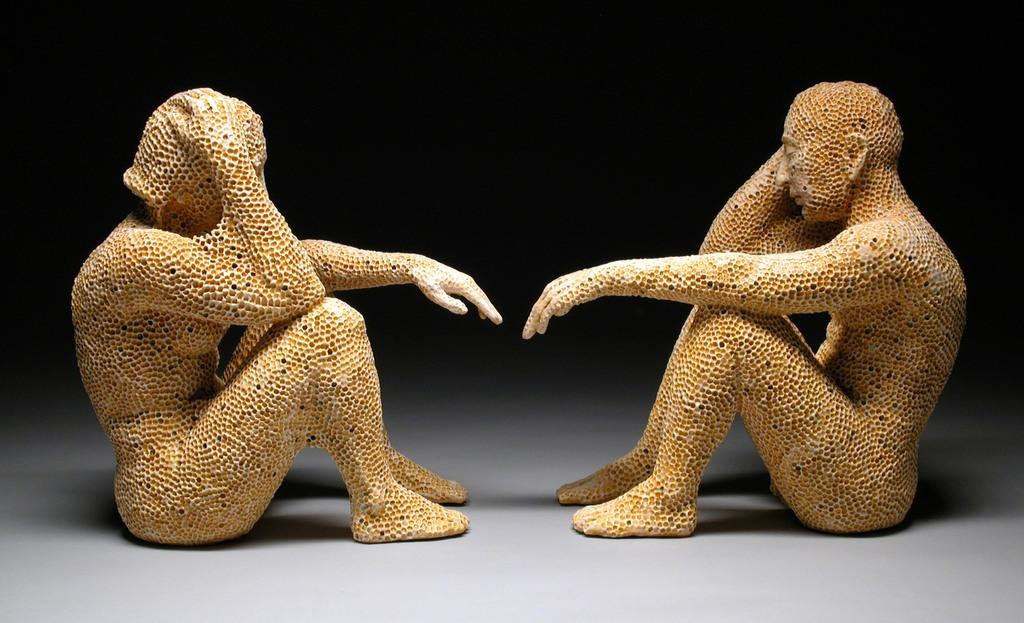What is depicted in the image? There are statues of two people in the image. What colors are the statues? The statues are in cream and brown colors. What is the surface on which the statues are placed? The statues are on a white color surface. What color is the background of the image? The background of the image is black. What subject is the person in the image teaching? There is no person present in the image, only statues. Therefore, teaching is not taking place in the image. 